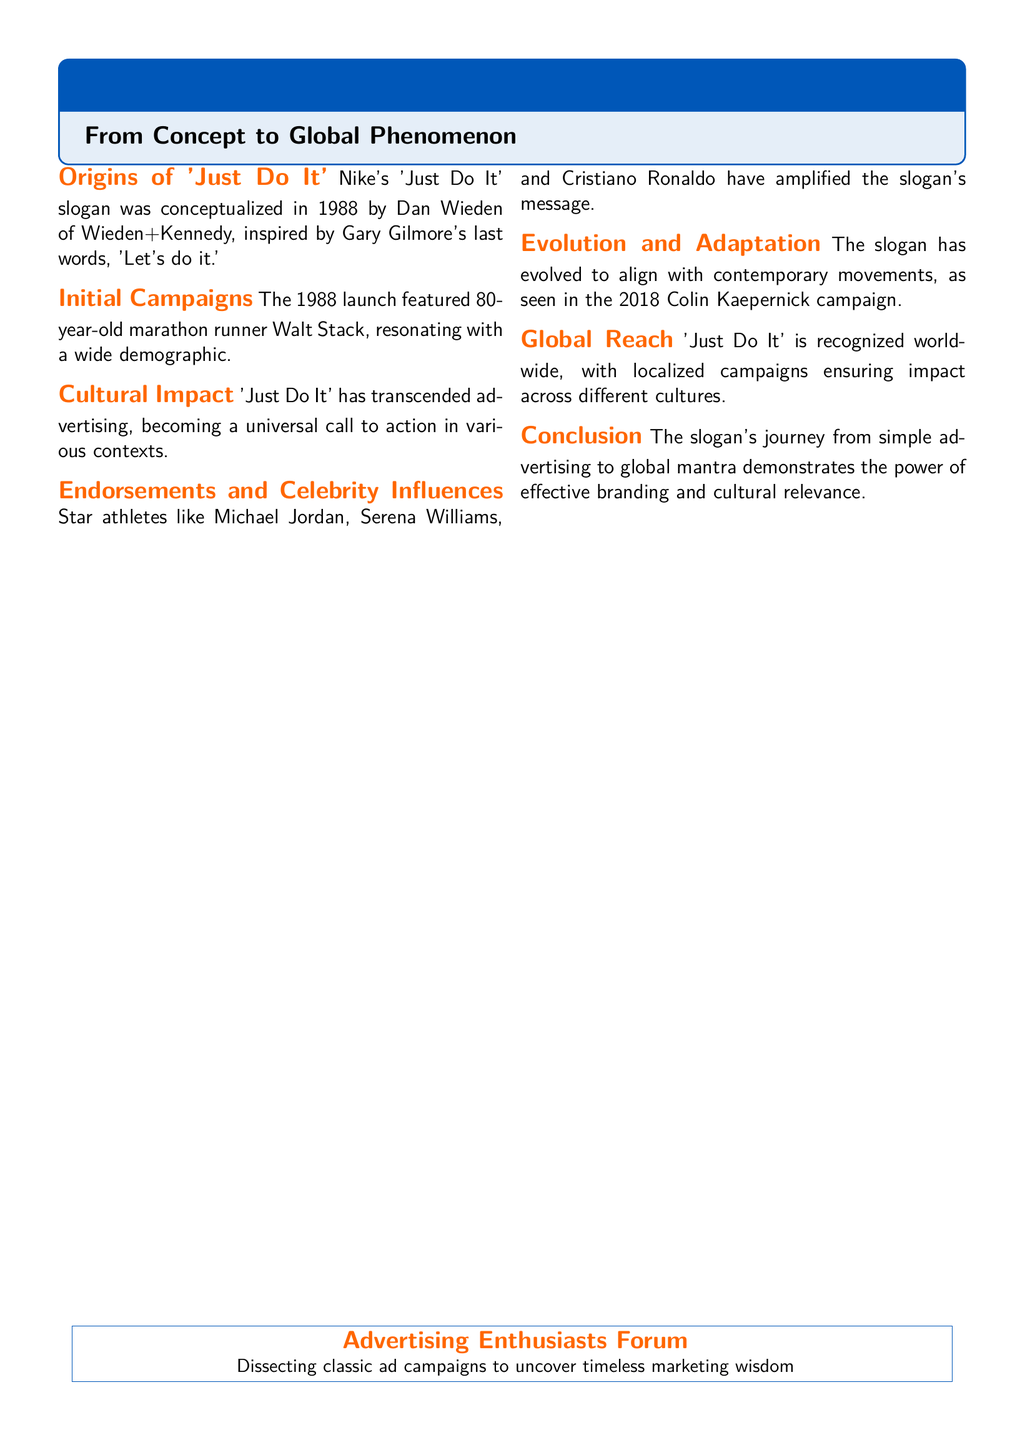What year was 'Just Do It' conceptualized? The slogan was conceptualized in 1988, as mentioned in the section regarding its origins.
Answer: 1988 Who was inspired by the phrase 'Let's do it'? Dan Wieden of Wieden+Kennedy conceptualized the slogan, inspired by Gary Gilmore's last words.
Answer: Gary Gilmore What athlete was featured in the initial campaign? The initial campaign featured 80-year-old marathon runner Walt Stack.
Answer: Walt Stack In what year did the Colin Kaepernick campaign take place? The Colin Kaepernick campaign mentioned in the document occurred in 2018.
Answer: 2018 What type of cultural impact has 'Just Do It' achieved? The slogan has become a universal call to action beyond advertising.
Answer: Universal call to action Which athletes have amplified the slogan's message? Star athletes like Michael Jordan, Serena Williams, and Cristiano Ronaldo are noted for amplifying the message.
Answer: Michael Jordan, Serena Williams, Cristiano Ronaldo What aspect of the slogan reflects its adaptability? The slogan has evolved to align with contemporary movements.
Answer: Contemporary movements What is the main theme of the document? The document discusses the evolution of Nike's 'Just Do It' slogan from concept to a global phenomenon.
Answer: Evolution of Nike's 'Just Do It' What does the Advertising Enthusiasts Forum focus on? The forum is dedicated to dissecting classic ad campaigns for insights into marketing.
Answer: Dissecting classic ad campaigns 